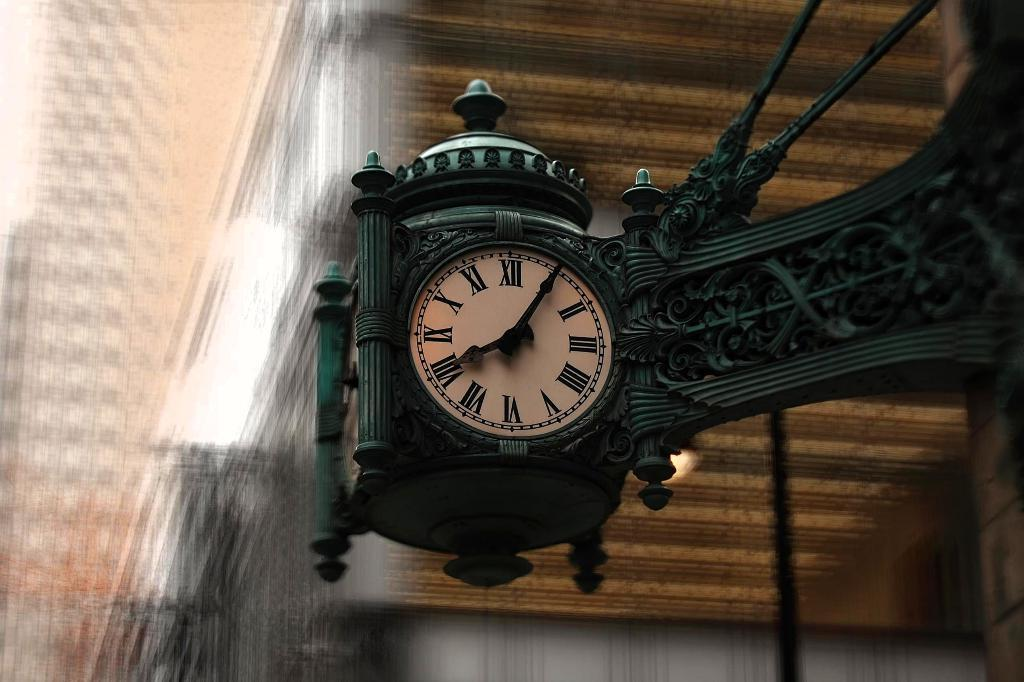<image>
Render a clear and concise summary of the photo. According to the clock it is 5 minutes after 8 o'clock. 